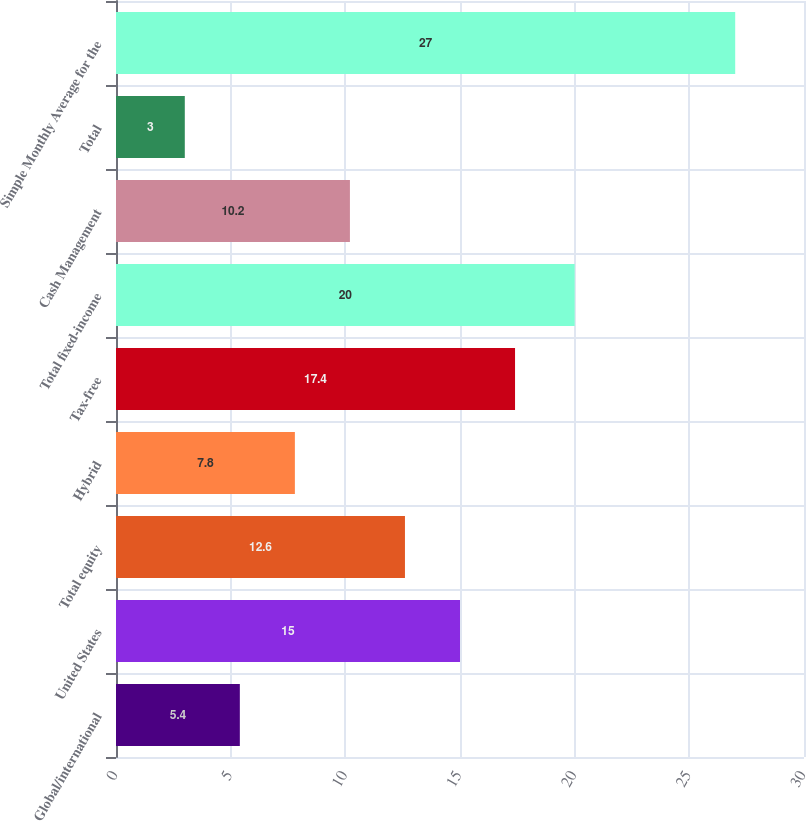Convert chart. <chart><loc_0><loc_0><loc_500><loc_500><bar_chart><fcel>Global/international<fcel>United States<fcel>Total equity<fcel>Hybrid<fcel>Tax-free<fcel>Total fixed-income<fcel>Cash Management<fcel>Total<fcel>Simple Monthly Average for the<nl><fcel>5.4<fcel>15<fcel>12.6<fcel>7.8<fcel>17.4<fcel>20<fcel>10.2<fcel>3<fcel>27<nl></chart> 